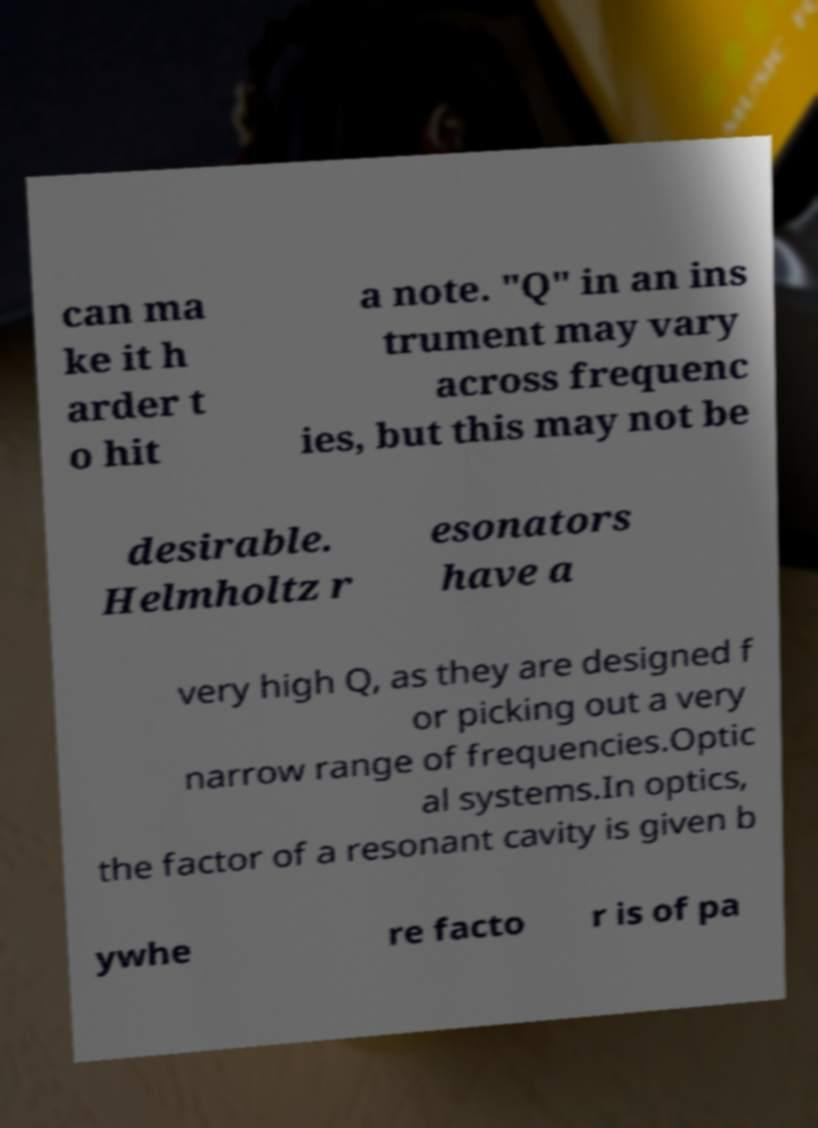Could you assist in decoding the text presented in this image and type it out clearly? can ma ke it h arder t o hit a note. "Q" in an ins trument may vary across frequenc ies, but this may not be desirable. Helmholtz r esonators have a very high Q, as they are designed f or picking out a very narrow range of frequencies.Optic al systems.In optics, the factor of a resonant cavity is given b ywhe re facto r is of pa 